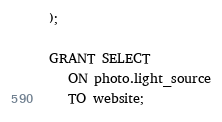Convert code to text. <code><loc_0><loc_0><loc_500><loc_500><_SQL_>);

GRANT SELECT
   ON photo.light_source
   TO website;
</code> 